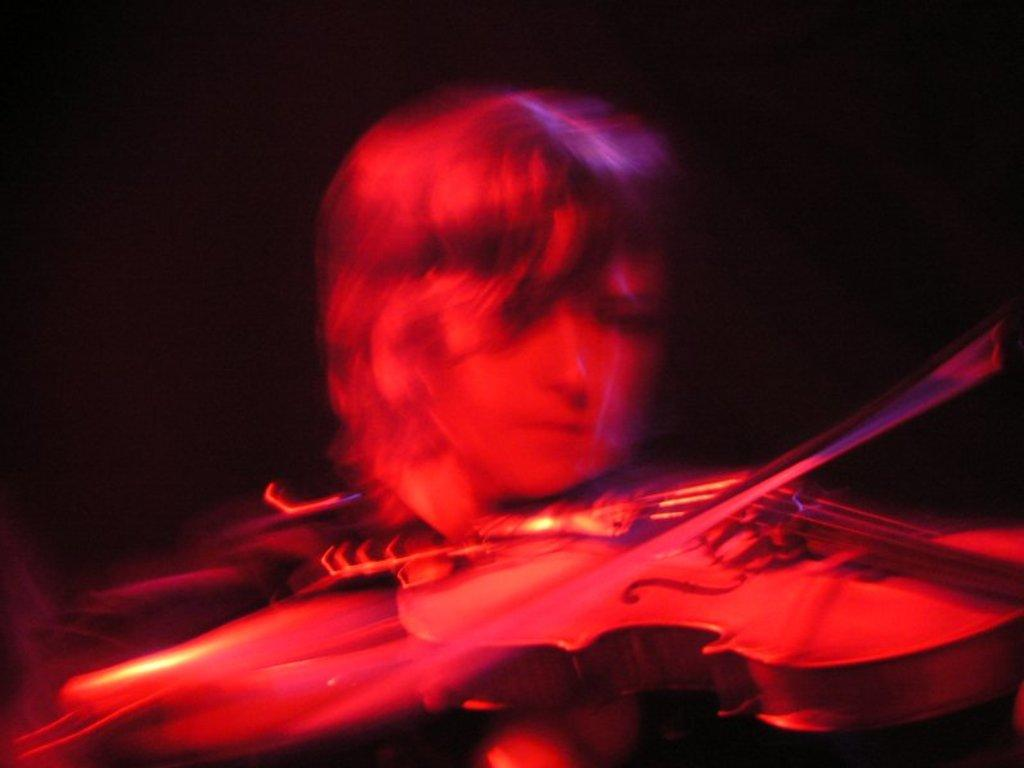What is the main subject of the image? There is a person in the image. What is the person doing in the image? The person is holding a musical instrument. Can you describe the background of the image? The background of the image is dark. What type of basin can be seen in the image? There is no basin present in the image. What sound does the person make while holding the musical instrument in the image? The image does not provide any information about the sound being made, as it is a still image. 